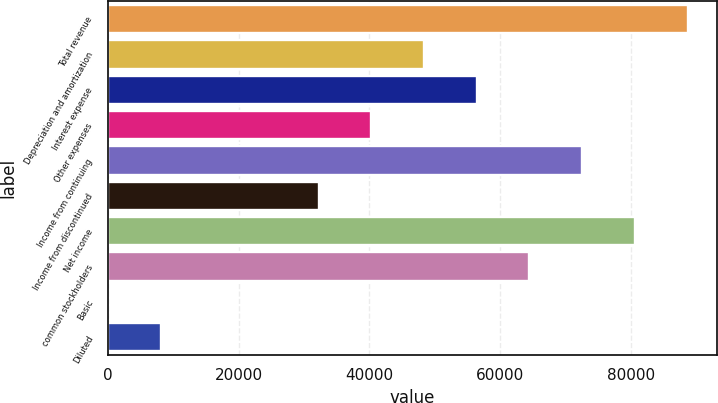Convert chart to OTSL. <chart><loc_0><loc_0><loc_500><loc_500><bar_chart><fcel>Total revenue<fcel>Depreciation and amortization<fcel>Interest expense<fcel>Other expenses<fcel>Income from continuing<fcel>Income from discontinued<fcel>Net income<fcel>common stockholders<fcel>Basic<fcel>Diluted<nl><fcel>88710.5<fcel>48387.7<fcel>56452.3<fcel>40323.1<fcel>72581.4<fcel>32258.5<fcel>80646<fcel>64516.8<fcel>0.27<fcel>8064.84<nl></chart> 